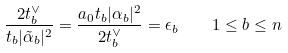Convert formula to latex. <formula><loc_0><loc_0><loc_500><loc_500>\frac { 2 t ^ { \vee } _ { b } } { t _ { b } | \tilde { \alpha } _ { b } | ^ { 2 } } = \frac { a _ { 0 } t _ { b } | \alpha _ { b } | ^ { 2 } } { 2 t ^ { \vee } _ { b } } = \epsilon _ { b } \quad 1 \leq b \leq n</formula> 